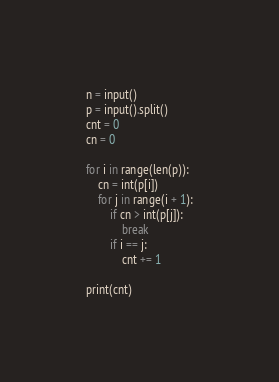Convert code to text. <code><loc_0><loc_0><loc_500><loc_500><_Python_>n = input()
p = input().split()
cnt = 0
cn = 0

for i in range(len(p)):
	cn = int(p[i])
	for j in range(i + 1):
		if cn > int(p[j]):
			break
		if i == j:
			cnt += 1

print(cnt)</code> 